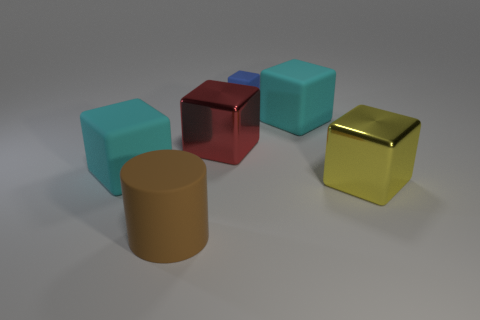There is a blue cube on the right side of the brown rubber object; how big is it?
Ensure brevity in your answer.  Small. Is the number of yellow metallic things to the left of the large red thing the same as the number of small cyan metallic balls?
Provide a short and direct response. Yes. Are there any other big objects of the same shape as the red shiny thing?
Your answer should be very brief. Yes. Is the big brown thing made of the same material as the big cyan object that is on the right side of the brown matte cylinder?
Give a very brief answer. Yes. Are there any metal things behind the large yellow metal block?
Make the answer very short. Yes. How many objects are either large rubber cylinders or big cyan cubes behind the large red thing?
Provide a succinct answer. 2. What is the color of the big thing that is in front of the yellow shiny cube that is in front of the small blue thing?
Give a very brief answer. Brown. What number of other things are there of the same material as the red thing
Provide a short and direct response. 1. How many metallic things are either small cyan blocks or large blocks?
Your answer should be very brief. 2. What color is the other small thing that is the same shape as the red thing?
Make the answer very short. Blue. 